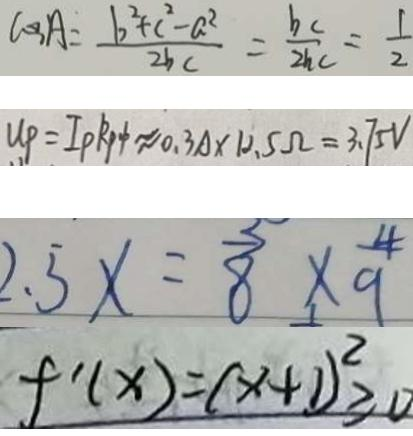<formula> <loc_0><loc_0><loc_500><loc_500>\cos A = \frac { b ^ { 2 } + c ^ { 2 } - a ^ { 2 } } { 2 b c } = \frac { b c } { 2 b c } = \frac { 1 } { 2 } 
 U P = I p R p \phi \approx 0 . 3 A \times 1 2 . 5 \Omega = 3 . 7 5 V 
 2 . 5 x = \frac { 5 } { 8 } \times \frac { 4 } { 9 } 
 f ^ { \prime } ( x ) = ( x + 1 ) ^ { 2 } \geq 0</formula> 